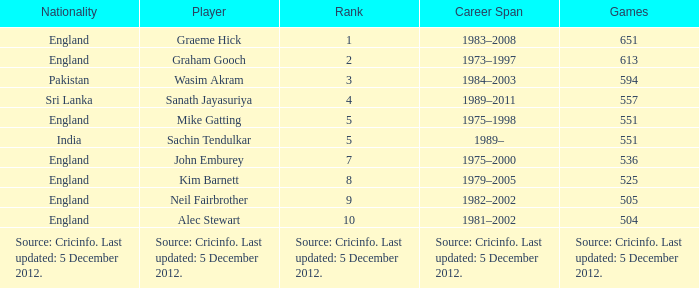What is Graham Gooch's nationality? England. 